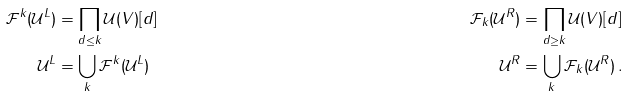<formula> <loc_0><loc_0><loc_500><loc_500>\mathcal { F } ^ { k } ( \mathcal { U } ^ { L } ) & = \prod _ { d \leq k } \mathcal { U } ( V ) [ d ] & \mathcal { F } _ { k } ( \mathcal { U } ^ { R } ) & = \prod _ { d \geq k } \mathcal { U } ( V ) [ d ] \\ \mathcal { U } ^ { L } & = \bigcup _ { k } \mathcal { F } ^ { k } ( \mathcal { U } ^ { L } ) & \mathcal { U } ^ { R } & = \bigcup _ { k } \mathcal { F } _ { k } ( \mathcal { U } ^ { R } ) \, .</formula> 